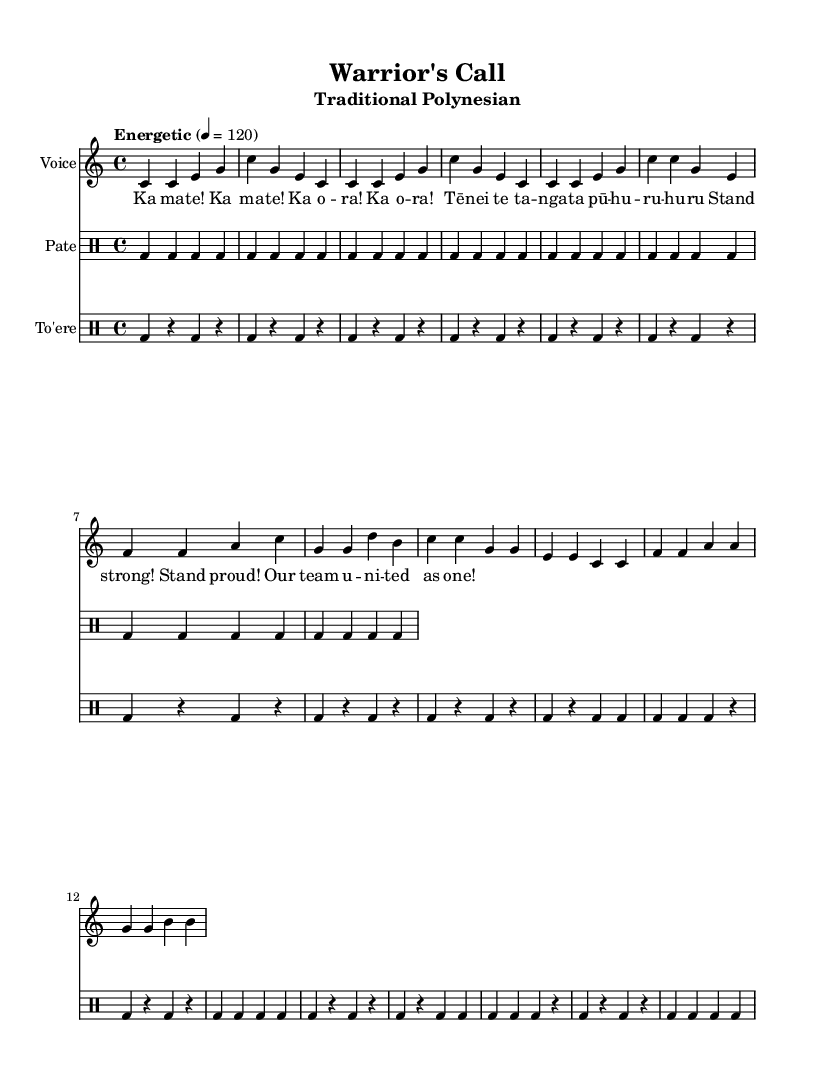What is the key signature of this music? The key signature is indicated by the clef and the number of sharps or flats at the beginning of the staff. In this case, the score shows a key signature of C major, which has no sharps or flats.
Answer: C major What is the time signature of this music? The time signature appears at the beginning of the score, represented by two numbers stacked on top of each other, indicating beats per measure and the note value of those beats. Here, it is 4/4, meaning four beats per measure, with the quarter note receiving one beat.
Answer: 4/4 What is the tempo marking for this piece? The tempo marking specifies the speed of the music, often indicated above the staff. In this score, it states "Energetic" with a metronome marking of 120 beats per minute, which indicates how fast the piece should be played.
Answer: 120 How many measures are in the melody section? To find the number of measures, we can count the different chunks separated by vertical lines. In the melody section, there are eight measures counted as individual groupings of notes.
Answer: 8 What type of percussion instruments are used in this piece? The percussion parts are labeled with specific instrument names directly in the score. In this case, there are two types mentioned: Pate and To'ere.
Answer: Pate, To'ere What is the lyrical theme of the verse? The lyrics provide a message that captures the essence of motivation and unity, emphasizing strength and pride. The verse lyrics mention "Ka ma -- te! Ka o -- ra!" which reflects a call to action and resilience.
Answer: Strength and unity 